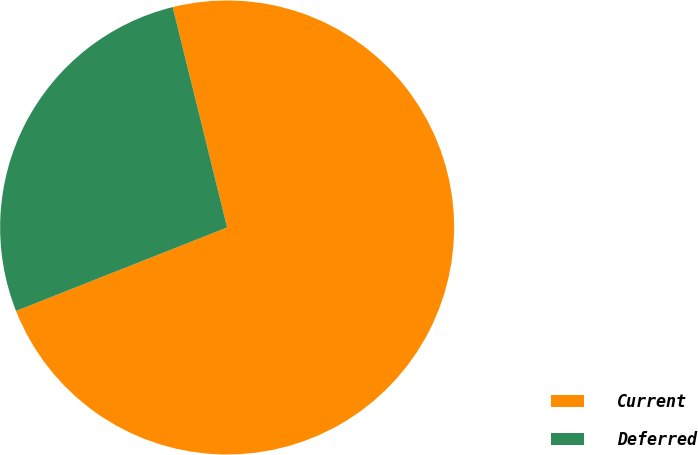Convert chart to OTSL. <chart><loc_0><loc_0><loc_500><loc_500><pie_chart><fcel>Current<fcel>Deferred<nl><fcel>72.86%<fcel>27.14%<nl></chart> 